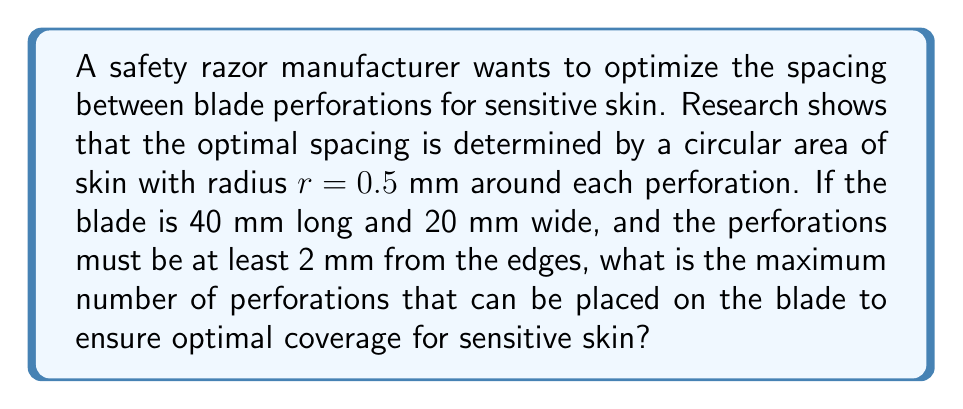Can you answer this question? Let's approach this step-by-step:

1) First, we need to calculate the usable area of the blade:
   Length: $40 - 2(2) = 36$ mm
   Width: $20 - 2(2) = 16$ mm
   Usable area: $A = 36 \times 16 = 576$ mm²

2) Each perforation covers a circular area with radius $r = 0.5$ mm.
   Area covered by each perforation: $A_p = \pi r^2 = \pi (0.5)^2 = 0.25\pi$ mm²

3) To ensure optimal coverage, these circles should be arranged in a hexagonal pattern, which provides the densest packing of circles. In this arrangement, the centers of the circles form equilateral triangles.

4) In a hexagonal packing, the area occupied by each circle is:
   $A_h = 2\sqrt{3}r^2 = 2\sqrt{3}(0.5)^2 = 0.5\sqrt{3}$ mm²

5) The number of perforations (N) can be calculated by dividing the usable area by the area occupied by each perforation in the hexagonal packing:

   $$N = \frac{A}{A_h} = \frac{576}{0.5\sqrt{3}} \approx 665.14$$

6) Since we can't have a fractional number of perforations, we round down to the nearest whole number.

[asy]
size(200);
fill(box((0,0),(36,16)),lightgrey);
for(int i=0; i<12; ++i)
  for(int j=0; j<7; ++j)
    fill(circle((3+i*3,2+j*2.6),0.5),white);
draw(box((0,0),(40,20)));
label("40 mm",(-1,10),W);
label("20 mm",(20,21),N);
[/asy]
Answer: 665 perforations 